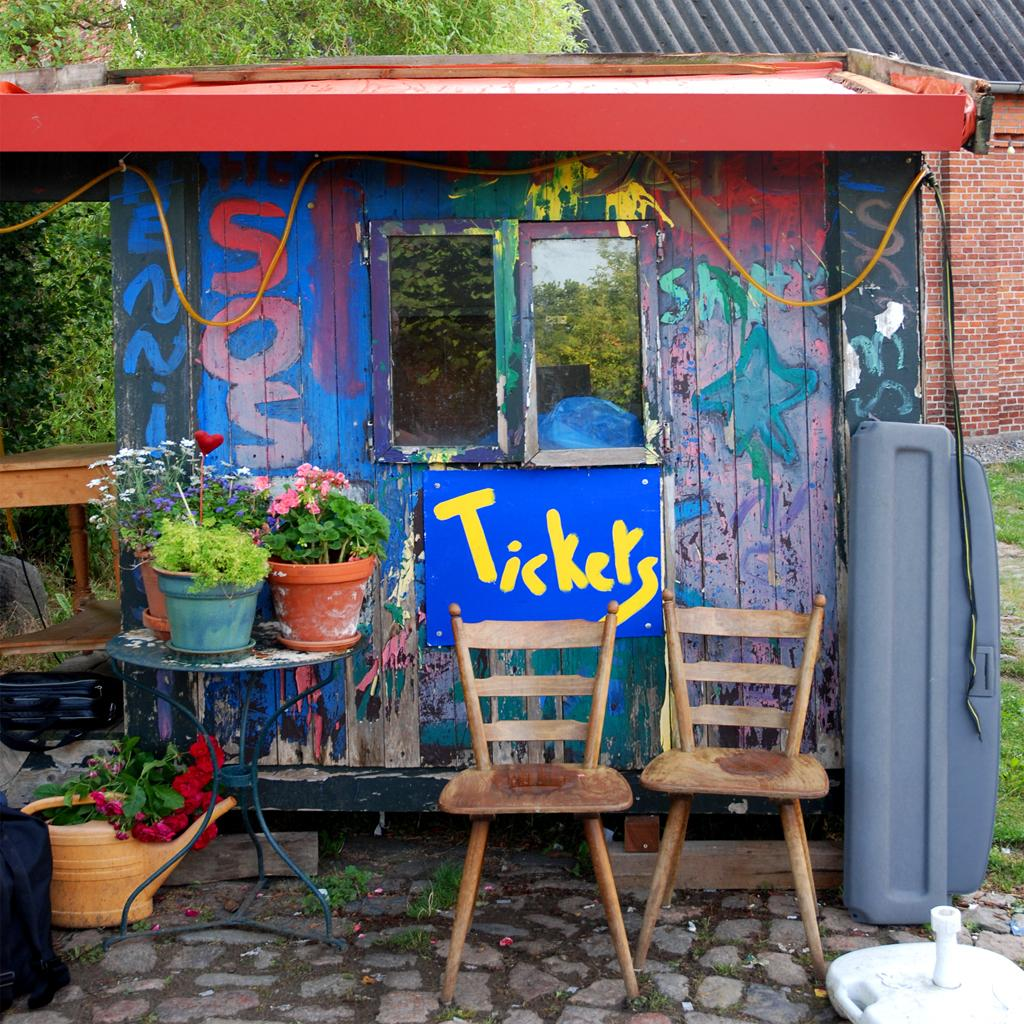How many chairs are in the image? There are two chairs in the image. What is on the table in the image? There are flower pots with plants on a table. What type of structure is visible in the image? There is a house with windows in the image. What can be seen in the background of the image? There is a tree and pipes visible in the background. Who is the owner of the straw in the image? There is no straw present in the image. Can you describe the rat in the image? There is no rat present in the image. 